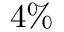<formula> <loc_0><loc_0><loc_500><loc_500>4 \%</formula> 